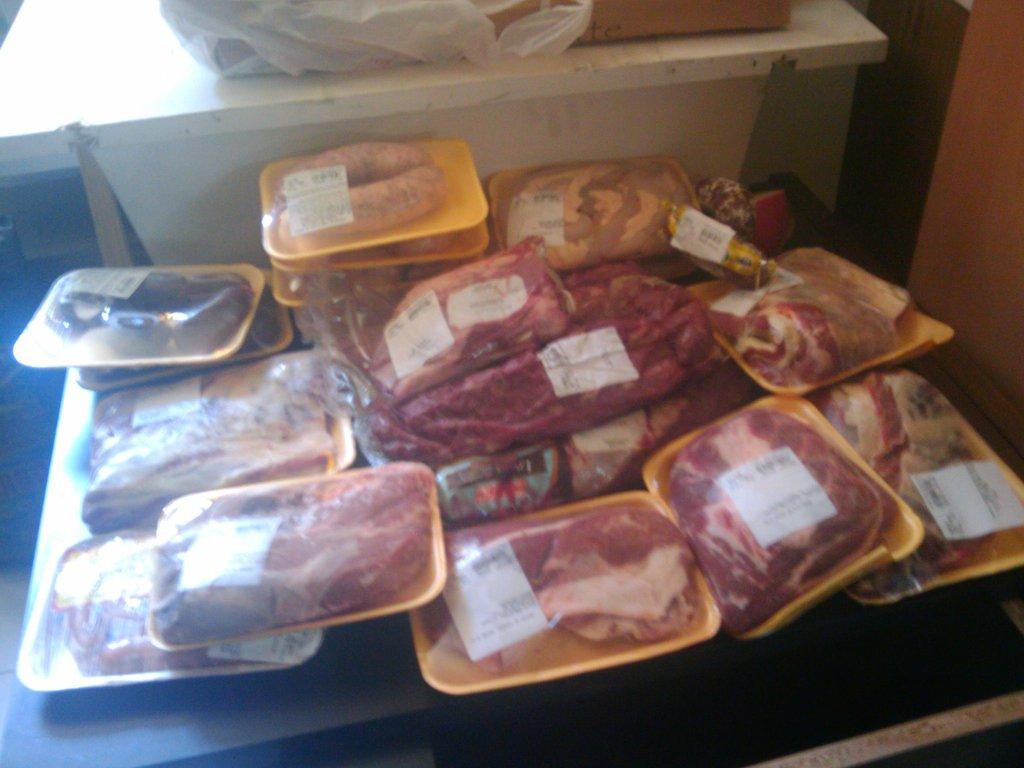Can you describe this image briefly? In the image we can see food items kept in a tray and it is wrapped in a cover, here we can see a label and a table, white in color. 